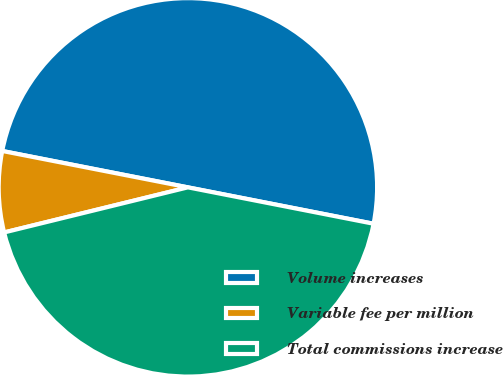Convert chart to OTSL. <chart><loc_0><loc_0><loc_500><loc_500><pie_chart><fcel>Volume increases<fcel>Variable fee per million<fcel>Total commissions increase<nl><fcel>50.0%<fcel>6.91%<fcel>43.09%<nl></chart> 